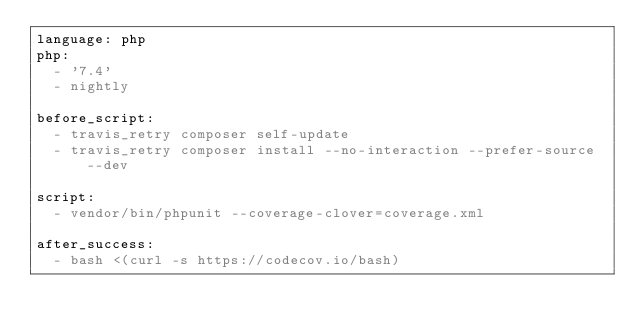Convert code to text. <code><loc_0><loc_0><loc_500><loc_500><_YAML_>language: php
php:
  - '7.4'
  - nightly

before_script:
  - travis_retry composer self-update
  - travis_retry composer install --no-interaction --prefer-source --dev

script:
  - vendor/bin/phpunit --coverage-clover=coverage.xml

after_success:
  - bash <(curl -s https://codecov.io/bash)</code> 